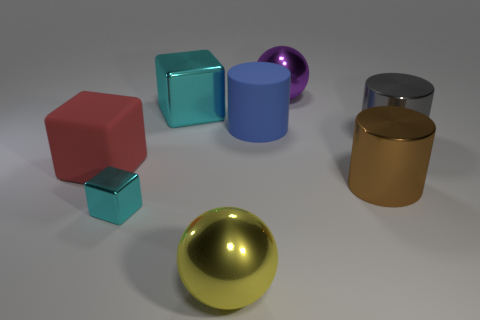Add 1 big red matte balls. How many objects exist? 9 Subtract all cubes. How many objects are left? 5 Add 2 big purple shiny things. How many big purple shiny things are left? 3 Add 5 large metallic objects. How many large metallic objects exist? 10 Subtract 0 green cylinders. How many objects are left? 8 Subtract all gray metallic cylinders. Subtract all big yellow objects. How many objects are left? 6 